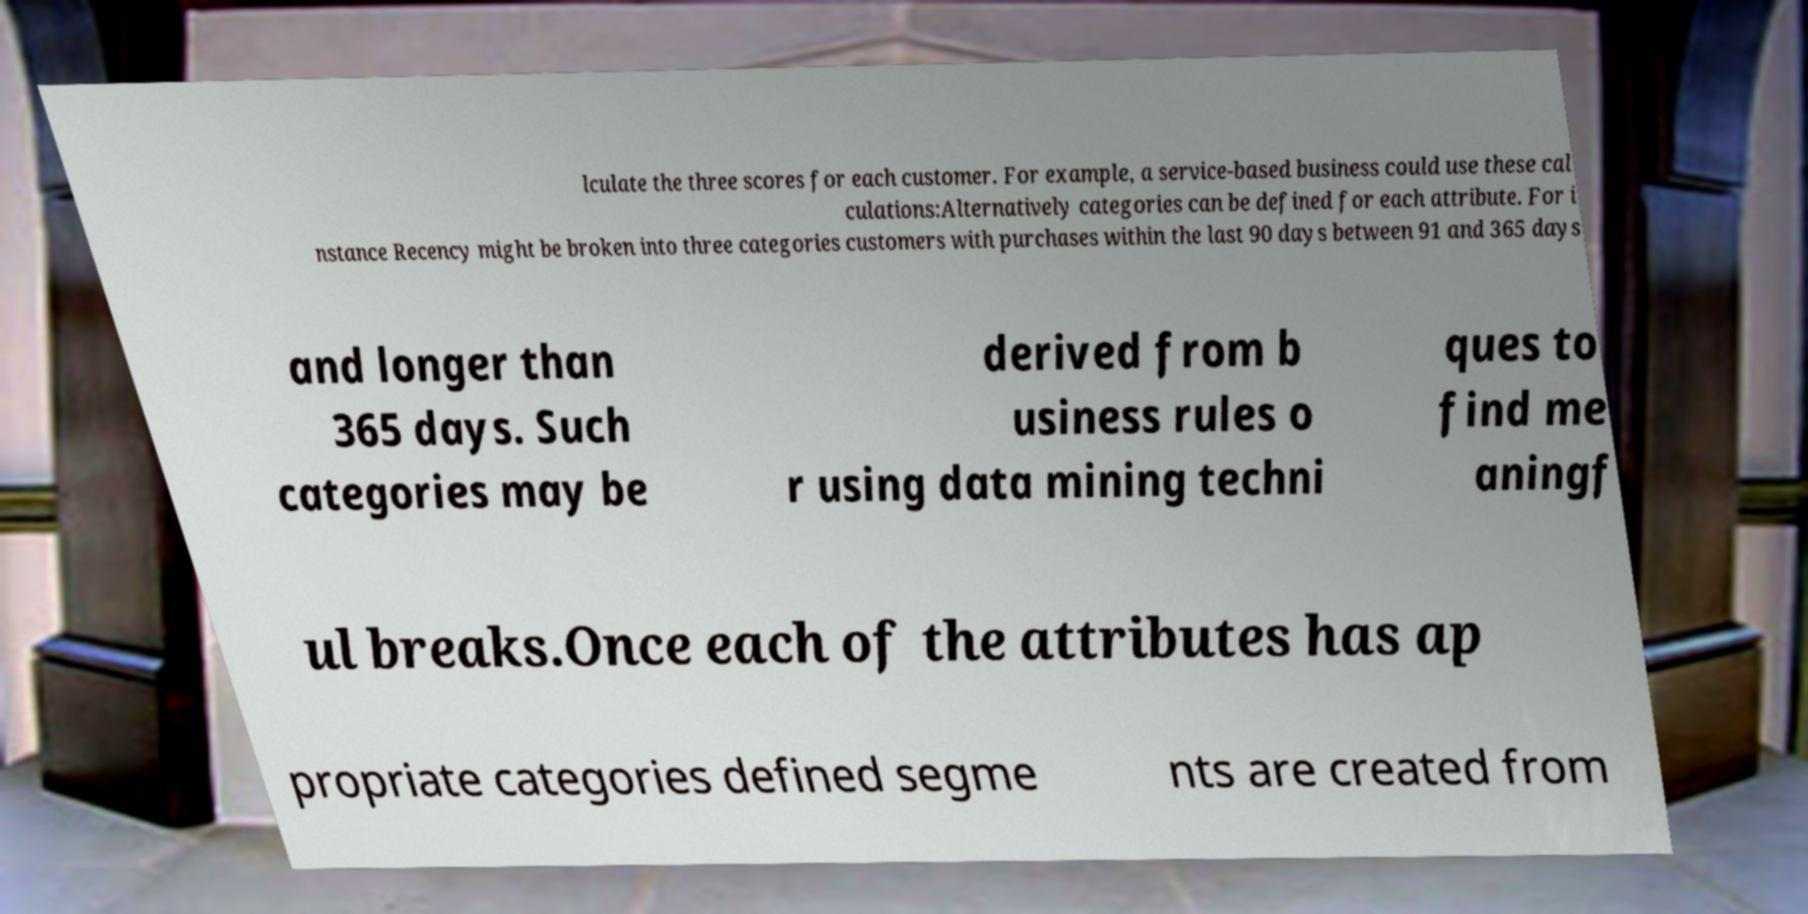I need the written content from this picture converted into text. Can you do that? lculate the three scores for each customer. For example, a service-based business could use these cal culations:Alternatively categories can be defined for each attribute. For i nstance Recency might be broken into three categories customers with purchases within the last 90 days between 91 and 365 days and longer than 365 days. Such categories may be derived from b usiness rules o r using data mining techni ques to find me aningf ul breaks.Once each of the attributes has ap propriate categories defined segme nts are created from 